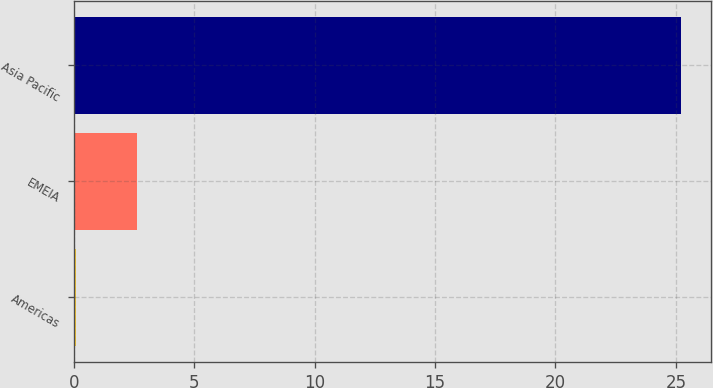<chart> <loc_0><loc_0><loc_500><loc_500><bar_chart><fcel>Americas<fcel>EMEIA<fcel>Asia Pacific<nl><fcel>0.1<fcel>2.61<fcel>25.2<nl></chart> 